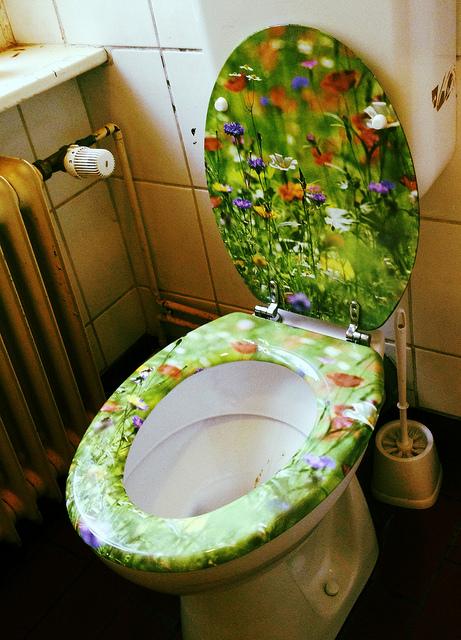What is behind the toilet?
Concise answer only. Toilet brush. Is this a normal toilet seat like everyone else?
Write a very short answer. No. Would you use that toilet?
Quick response, please. Yes. 